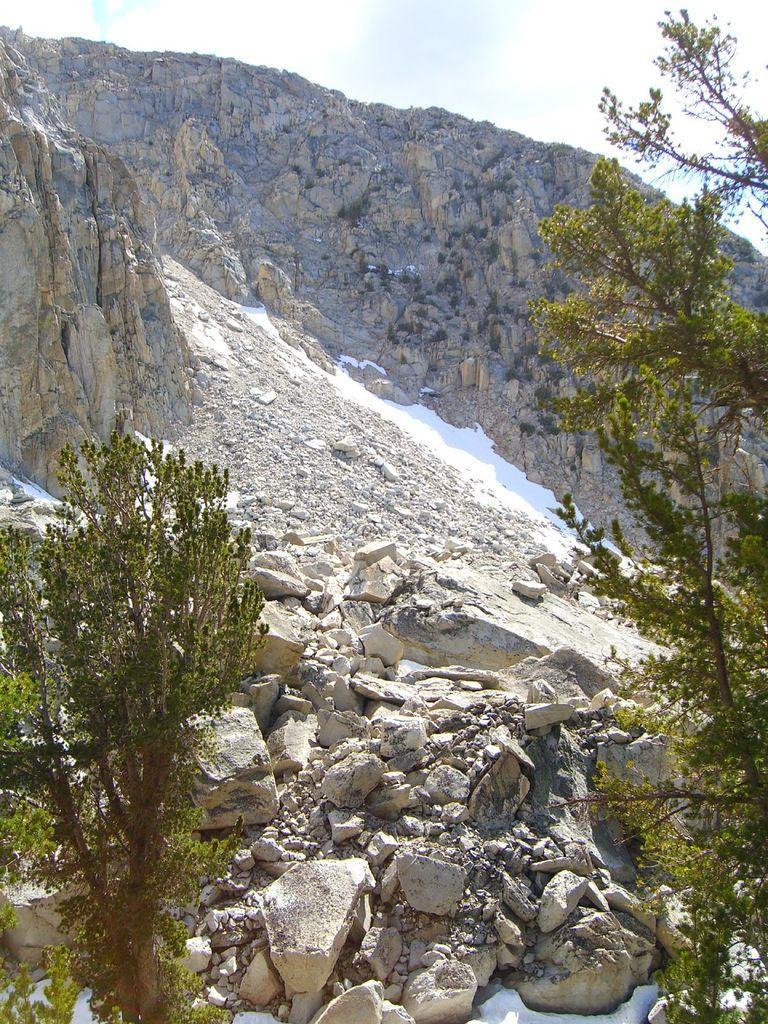Please provide a concise description of this image. On the left side of the image and right side of the image there are trees. In this image I can see rocks, mountain and sky. 